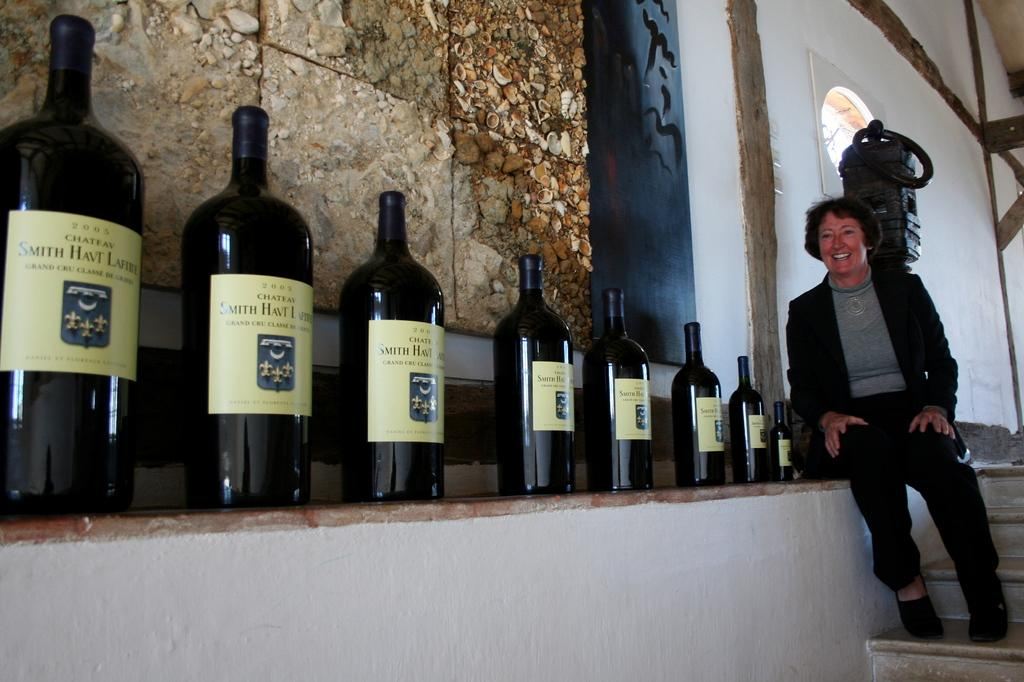What is placed on the wall in the image? There are beverage bottles placed on the wall in the image. Where is the woman located in the image? The woman is sitting at the stairs on the right side of the image. What can be seen in the background of the image? There is a wall and a ventilator in the background of the image. Are there any plants growing in a circle in the image? There are no plants or circles present in the image. Can you see any animals from a zoo in the image? There are no animals or references to a zoo in the image. 